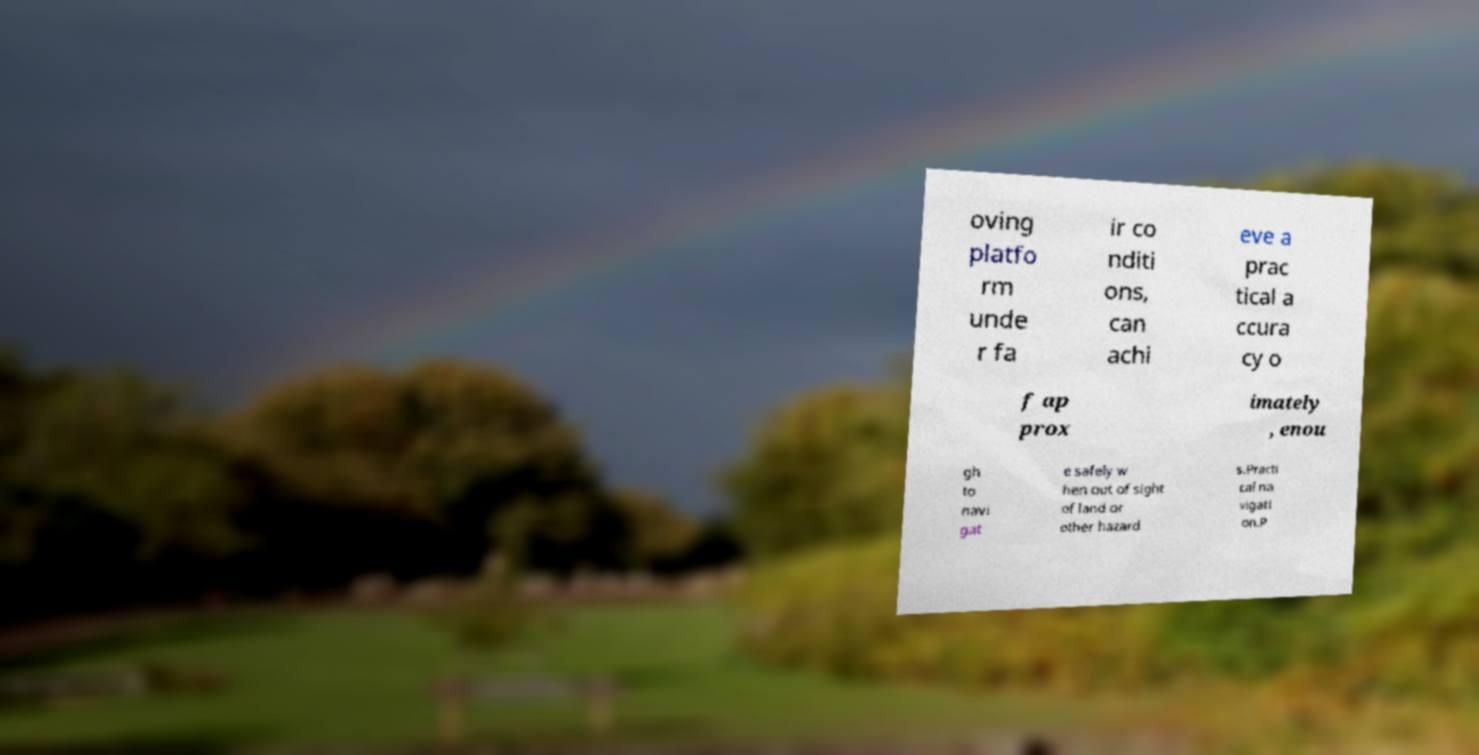What messages or text are displayed in this image? I need them in a readable, typed format. oving platfo rm unde r fa ir co nditi ons, can achi eve a prac tical a ccura cy o f ap prox imately , enou gh to navi gat e safely w hen out of sight of land or other hazard s.Practi cal na vigati on.P 